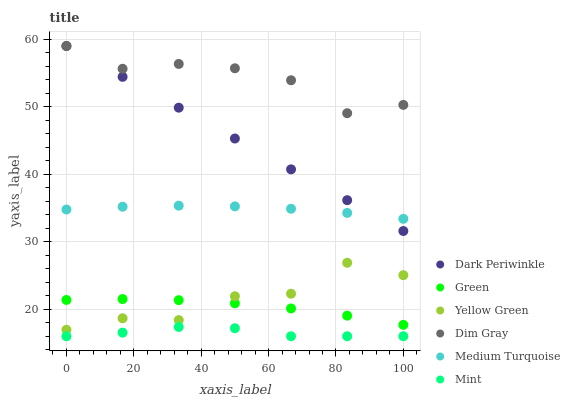Does Mint have the minimum area under the curve?
Answer yes or no. Yes. Does Dim Gray have the maximum area under the curve?
Answer yes or no. Yes. Does Yellow Green have the minimum area under the curve?
Answer yes or no. No. Does Yellow Green have the maximum area under the curve?
Answer yes or no. No. Is Dark Periwinkle the smoothest?
Answer yes or no. Yes. Is Yellow Green the roughest?
Answer yes or no. Yes. Is Green the smoothest?
Answer yes or no. No. Is Green the roughest?
Answer yes or no. No. Does Mint have the lowest value?
Answer yes or no. Yes. Does Yellow Green have the lowest value?
Answer yes or no. No. Does Dark Periwinkle have the highest value?
Answer yes or no. Yes. Does Yellow Green have the highest value?
Answer yes or no. No. Is Mint less than Yellow Green?
Answer yes or no. Yes. Is Dim Gray greater than Yellow Green?
Answer yes or no. Yes. Does Green intersect Yellow Green?
Answer yes or no. Yes. Is Green less than Yellow Green?
Answer yes or no. No. Is Green greater than Yellow Green?
Answer yes or no. No. Does Mint intersect Yellow Green?
Answer yes or no. No. 